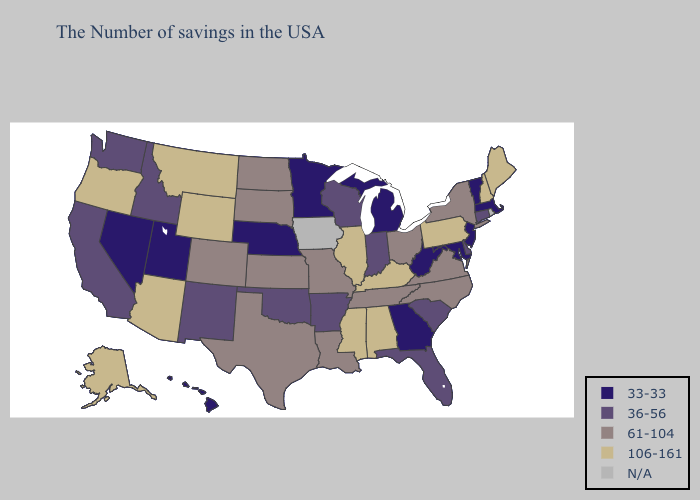What is the highest value in the West ?
Give a very brief answer. 106-161. What is the lowest value in the Northeast?
Quick response, please. 33-33. Does Arkansas have the highest value in the USA?
Answer briefly. No. Does Washington have the lowest value in the USA?
Concise answer only. No. Among the states that border New Mexico , does Colorado have the lowest value?
Keep it brief. No. Name the states that have a value in the range 36-56?
Write a very short answer. Connecticut, Delaware, South Carolina, Florida, Indiana, Wisconsin, Arkansas, Oklahoma, New Mexico, Idaho, California, Washington. Which states have the lowest value in the West?
Quick response, please. Utah, Nevada, Hawaii. Name the states that have a value in the range 36-56?
Be succinct. Connecticut, Delaware, South Carolina, Florida, Indiana, Wisconsin, Arkansas, Oklahoma, New Mexico, Idaho, California, Washington. What is the value of Delaware?
Give a very brief answer. 36-56. Is the legend a continuous bar?
Short answer required. No. What is the highest value in the USA?
Quick response, please. 106-161. What is the value of Indiana?
Give a very brief answer. 36-56. 